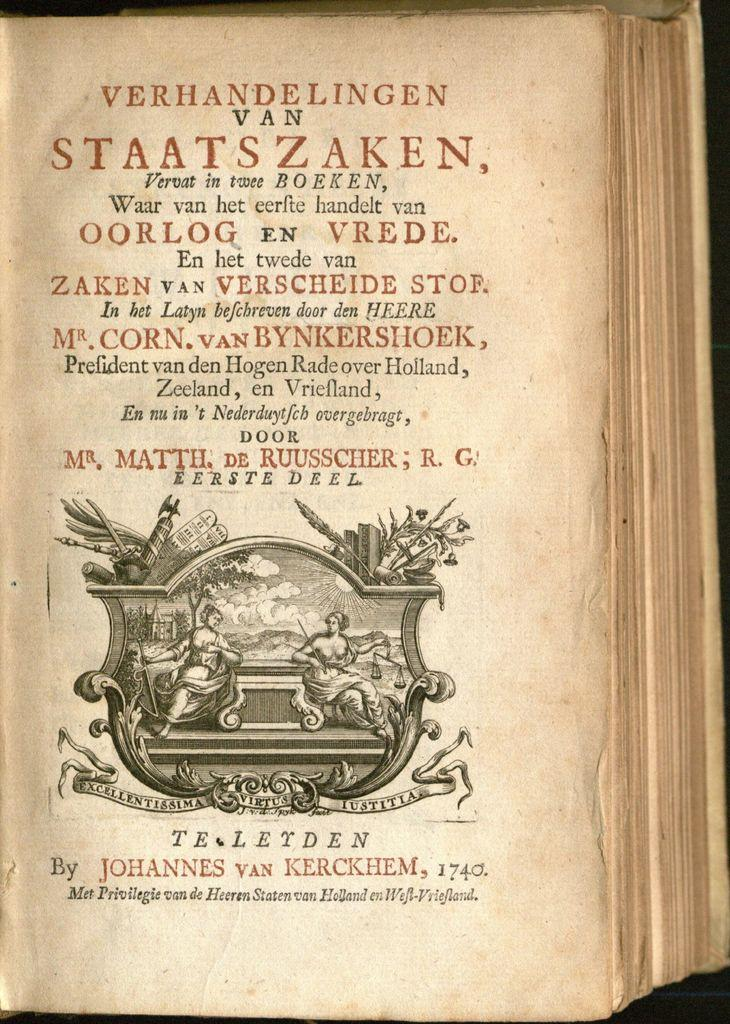<image>
Describe the image concisely. A single page of an old book by Johannes van kerckhem. 